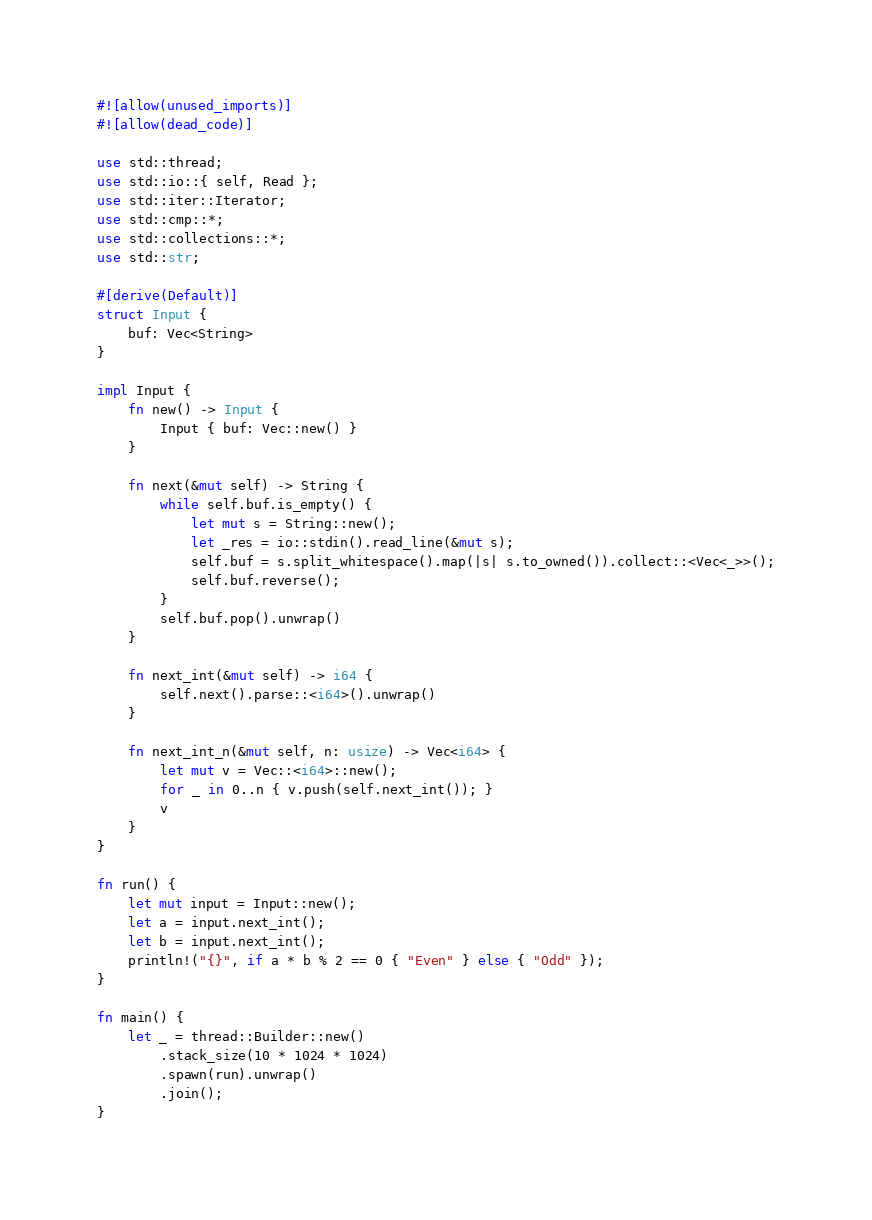<code> <loc_0><loc_0><loc_500><loc_500><_Rust_>#![allow(unused_imports)]
#![allow(dead_code)]

use std::thread;
use std::io::{ self, Read };
use std::iter::Iterator;
use std::cmp::*;
use std::collections::*;
use std::str;

#[derive(Default)]
struct Input {
    buf: Vec<String>
}

impl Input {
    fn new() -> Input {
        Input { buf: Vec::new() }
    }

    fn next(&mut self) -> String {
        while self.buf.is_empty() {
            let mut s = String::new();
            let _res = io::stdin().read_line(&mut s);
            self.buf = s.split_whitespace().map(|s| s.to_owned()).collect::<Vec<_>>();
            self.buf.reverse();
        }
        self.buf.pop().unwrap()
    }

    fn next_int(&mut self) -> i64 {
        self.next().parse::<i64>().unwrap()
    }

    fn next_int_n(&mut self, n: usize) -> Vec<i64> {
        let mut v = Vec::<i64>::new();
        for _ in 0..n { v.push(self.next_int()); }
        v
    }
}

fn run() {
    let mut input = Input::new();
    let a = input.next_int();
    let b = input.next_int();
    println!("{}", if a * b % 2 == 0 { "Even" } else { "Odd" });
}

fn main() {
    let _ = thread::Builder::new()
        .stack_size(10 * 1024 * 1024)
        .spawn(run).unwrap()
        .join();
}</code> 